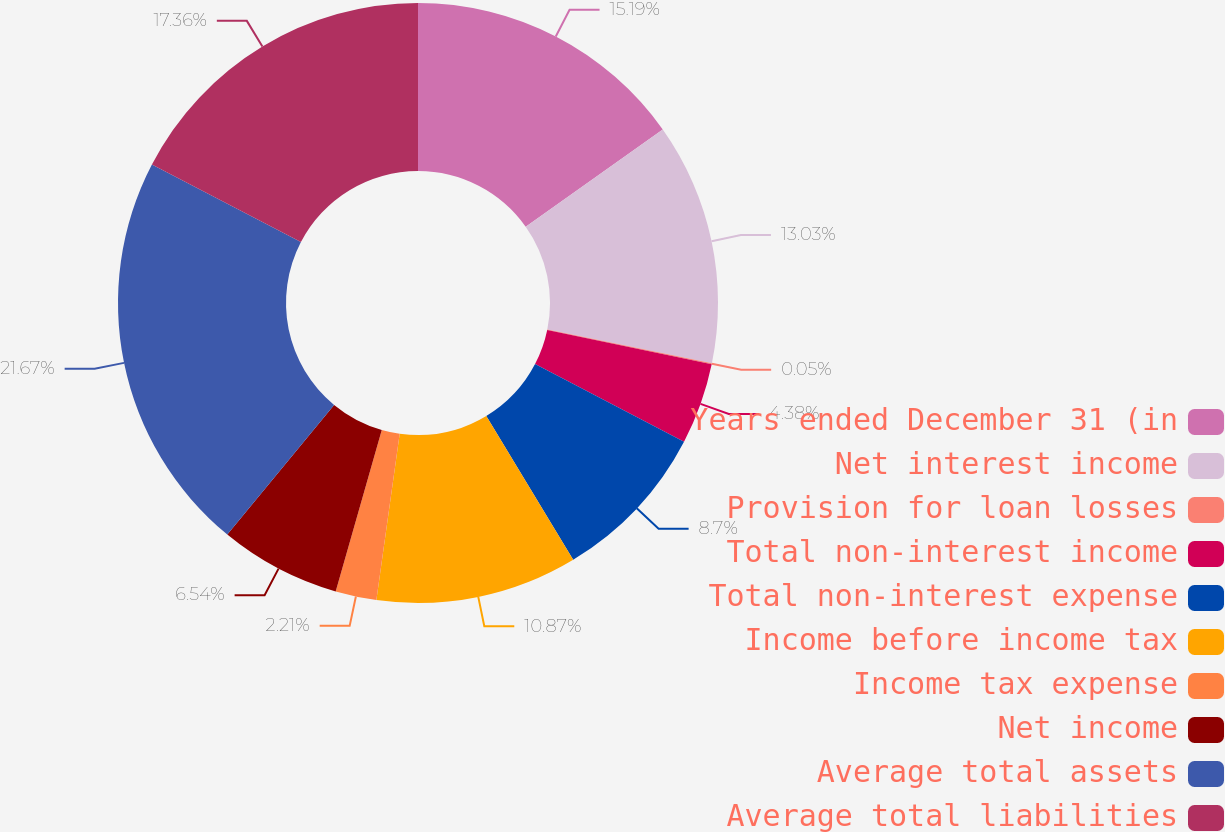Convert chart to OTSL. <chart><loc_0><loc_0><loc_500><loc_500><pie_chart><fcel>Years ended December 31 (in<fcel>Net interest income<fcel>Provision for loan losses<fcel>Total non-interest income<fcel>Total non-interest expense<fcel>Income before income tax<fcel>Income tax expense<fcel>Net income<fcel>Average total assets<fcel>Average total liabilities<nl><fcel>15.19%<fcel>13.03%<fcel>0.05%<fcel>4.38%<fcel>8.7%<fcel>10.87%<fcel>2.21%<fcel>6.54%<fcel>21.68%<fcel>17.36%<nl></chart> 